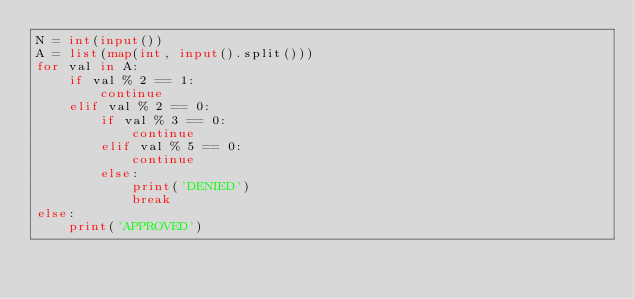Convert code to text. <code><loc_0><loc_0><loc_500><loc_500><_Python_>N = int(input())
A = list(map(int, input().split()))
for val in A:
    if val % 2 == 1:
        continue
    elif val % 2 == 0:
        if val % 3 == 0:
            continue
        elif val % 5 == 0:
            continue
        else:
            print('DENIED')
            break
else:
    print('APPROVED')</code> 